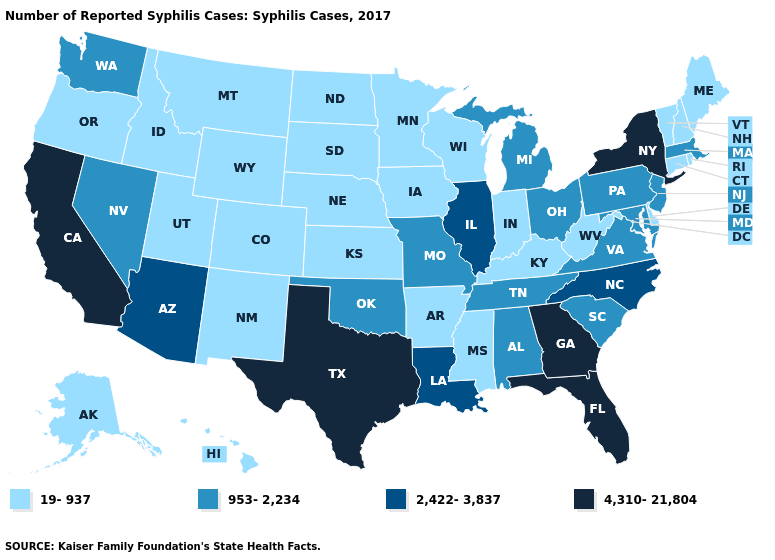Does the first symbol in the legend represent the smallest category?
Answer briefly. Yes. What is the value of Delaware?
Answer briefly. 19-937. What is the value of Arizona?
Give a very brief answer. 2,422-3,837. What is the value of Michigan?
Give a very brief answer. 953-2,234. Name the states that have a value in the range 19-937?
Answer briefly. Alaska, Arkansas, Colorado, Connecticut, Delaware, Hawaii, Idaho, Indiana, Iowa, Kansas, Kentucky, Maine, Minnesota, Mississippi, Montana, Nebraska, New Hampshire, New Mexico, North Dakota, Oregon, Rhode Island, South Dakota, Utah, Vermont, West Virginia, Wisconsin, Wyoming. What is the value of Hawaii?
Be succinct. 19-937. What is the highest value in states that border Montana?
Short answer required. 19-937. What is the value of Pennsylvania?
Quick response, please. 953-2,234. What is the value of Kentucky?
Be succinct. 19-937. What is the lowest value in the West?
Concise answer only. 19-937. What is the value of California?
Concise answer only. 4,310-21,804. Name the states that have a value in the range 953-2,234?
Keep it brief. Alabama, Maryland, Massachusetts, Michigan, Missouri, Nevada, New Jersey, Ohio, Oklahoma, Pennsylvania, South Carolina, Tennessee, Virginia, Washington. Which states have the highest value in the USA?
Write a very short answer. California, Florida, Georgia, New York, Texas. Is the legend a continuous bar?
Quick response, please. No. Does the first symbol in the legend represent the smallest category?
Give a very brief answer. Yes. 